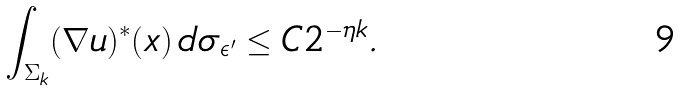<formula> <loc_0><loc_0><loc_500><loc_500>\int _ { \Sigma _ { k } } ( \nabla u ) ^ { * } ( x ) \, d \sigma _ { \epsilon ^ { \prime } } \leq C 2 ^ { - \eta k } .</formula> 